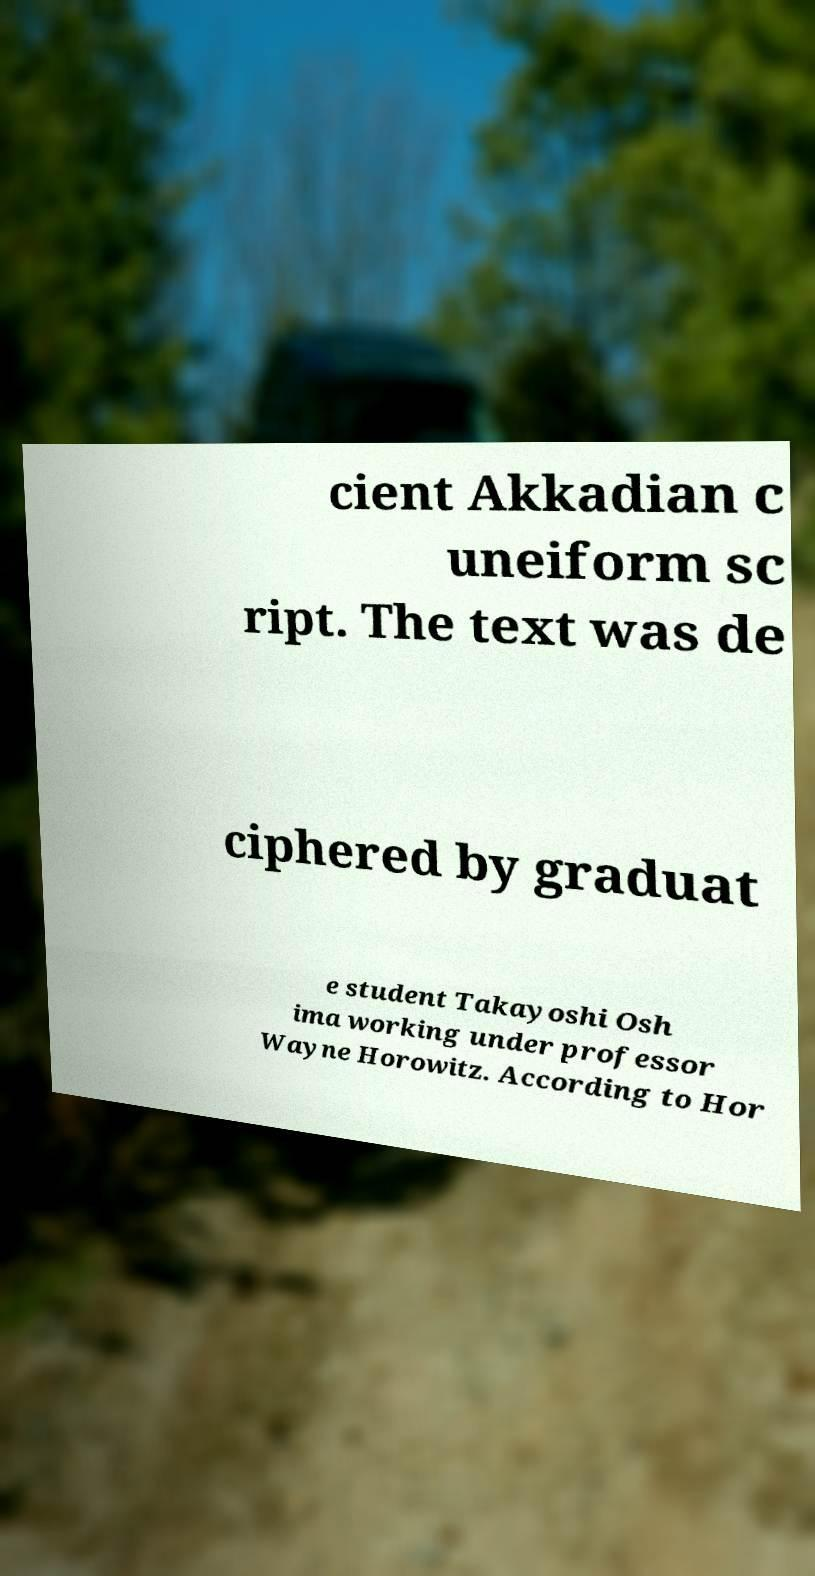Could you extract and type out the text from this image? cient Akkadian c uneiform sc ript. The text was de ciphered by graduat e student Takayoshi Osh ima working under professor Wayne Horowitz. According to Hor 